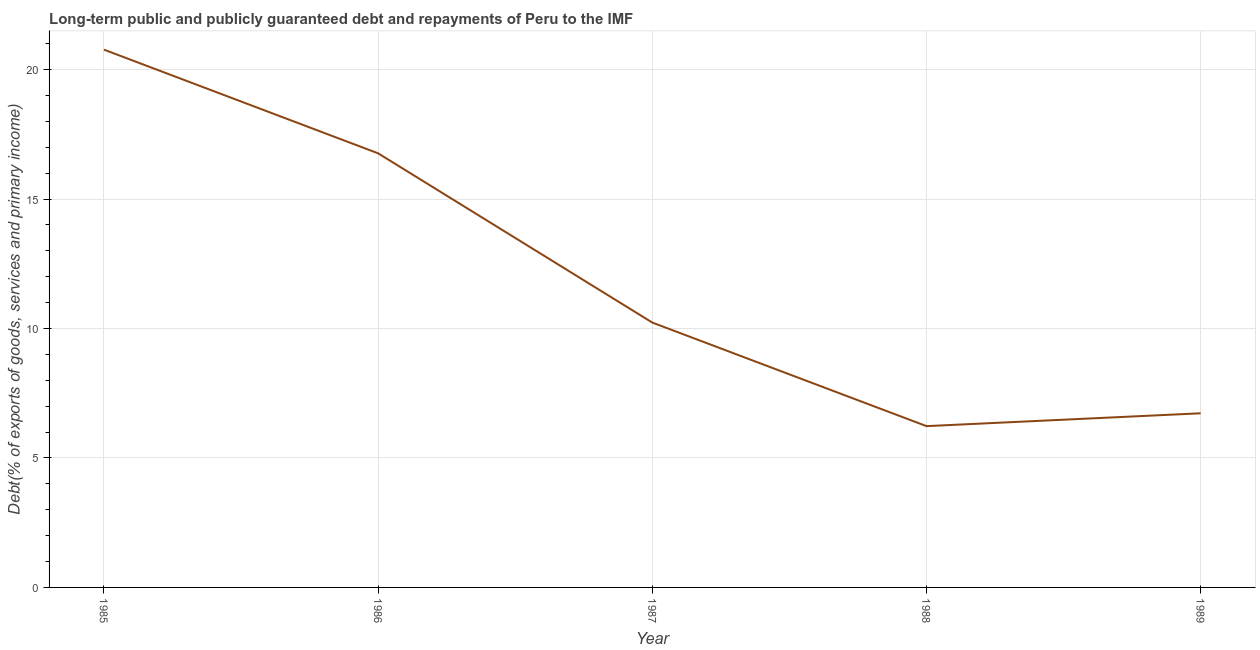What is the debt service in 1988?
Offer a very short reply. 6.23. Across all years, what is the maximum debt service?
Make the answer very short. 20.77. Across all years, what is the minimum debt service?
Your answer should be very brief. 6.23. In which year was the debt service maximum?
Your answer should be compact. 1985. In which year was the debt service minimum?
Ensure brevity in your answer.  1988. What is the sum of the debt service?
Offer a terse response. 60.72. What is the difference between the debt service in 1986 and 1989?
Keep it short and to the point. 10.04. What is the average debt service per year?
Your answer should be compact. 12.14. What is the median debt service?
Make the answer very short. 10.23. In how many years, is the debt service greater than 1 %?
Give a very brief answer. 5. What is the ratio of the debt service in 1985 to that in 1986?
Provide a succinct answer. 1.24. Is the debt service in 1986 less than that in 1988?
Offer a very short reply. No. What is the difference between the highest and the second highest debt service?
Ensure brevity in your answer.  4. Is the sum of the debt service in 1988 and 1989 greater than the maximum debt service across all years?
Give a very brief answer. No. What is the difference between the highest and the lowest debt service?
Your answer should be compact. 14.54. How many years are there in the graph?
Ensure brevity in your answer.  5. What is the difference between two consecutive major ticks on the Y-axis?
Your answer should be compact. 5. Are the values on the major ticks of Y-axis written in scientific E-notation?
Give a very brief answer. No. Does the graph contain any zero values?
Give a very brief answer. No. Does the graph contain grids?
Offer a terse response. Yes. What is the title of the graph?
Give a very brief answer. Long-term public and publicly guaranteed debt and repayments of Peru to the IMF. What is the label or title of the Y-axis?
Provide a short and direct response. Debt(% of exports of goods, services and primary income). What is the Debt(% of exports of goods, services and primary income) of 1985?
Provide a succinct answer. 20.77. What is the Debt(% of exports of goods, services and primary income) in 1986?
Your response must be concise. 16.76. What is the Debt(% of exports of goods, services and primary income) of 1987?
Offer a very short reply. 10.23. What is the Debt(% of exports of goods, services and primary income) in 1988?
Your response must be concise. 6.23. What is the Debt(% of exports of goods, services and primary income) of 1989?
Offer a terse response. 6.73. What is the difference between the Debt(% of exports of goods, services and primary income) in 1985 and 1986?
Ensure brevity in your answer.  4. What is the difference between the Debt(% of exports of goods, services and primary income) in 1985 and 1987?
Your answer should be compact. 10.54. What is the difference between the Debt(% of exports of goods, services and primary income) in 1985 and 1988?
Offer a very short reply. 14.54. What is the difference between the Debt(% of exports of goods, services and primary income) in 1985 and 1989?
Provide a short and direct response. 14.04. What is the difference between the Debt(% of exports of goods, services and primary income) in 1986 and 1987?
Offer a very short reply. 6.54. What is the difference between the Debt(% of exports of goods, services and primary income) in 1986 and 1988?
Make the answer very short. 10.54. What is the difference between the Debt(% of exports of goods, services and primary income) in 1986 and 1989?
Keep it short and to the point. 10.04. What is the difference between the Debt(% of exports of goods, services and primary income) in 1987 and 1988?
Keep it short and to the point. 4. What is the difference between the Debt(% of exports of goods, services and primary income) in 1987 and 1989?
Keep it short and to the point. 3.5. What is the difference between the Debt(% of exports of goods, services and primary income) in 1988 and 1989?
Provide a short and direct response. -0.5. What is the ratio of the Debt(% of exports of goods, services and primary income) in 1985 to that in 1986?
Your answer should be compact. 1.24. What is the ratio of the Debt(% of exports of goods, services and primary income) in 1985 to that in 1987?
Keep it short and to the point. 2.03. What is the ratio of the Debt(% of exports of goods, services and primary income) in 1985 to that in 1988?
Your answer should be very brief. 3.33. What is the ratio of the Debt(% of exports of goods, services and primary income) in 1985 to that in 1989?
Keep it short and to the point. 3.09. What is the ratio of the Debt(% of exports of goods, services and primary income) in 1986 to that in 1987?
Your answer should be compact. 1.64. What is the ratio of the Debt(% of exports of goods, services and primary income) in 1986 to that in 1988?
Your answer should be very brief. 2.69. What is the ratio of the Debt(% of exports of goods, services and primary income) in 1986 to that in 1989?
Give a very brief answer. 2.49. What is the ratio of the Debt(% of exports of goods, services and primary income) in 1987 to that in 1988?
Your response must be concise. 1.64. What is the ratio of the Debt(% of exports of goods, services and primary income) in 1987 to that in 1989?
Give a very brief answer. 1.52. What is the ratio of the Debt(% of exports of goods, services and primary income) in 1988 to that in 1989?
Provide a short and direct response. 0.93. 